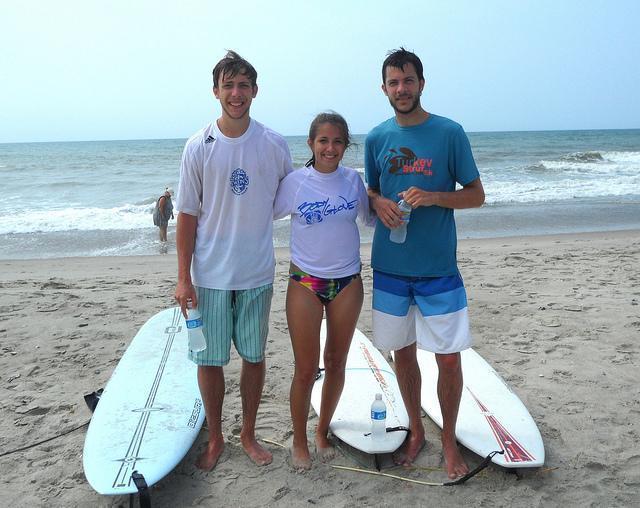How many surfboards are visible?
Give a very brief answer. 3. How many people are visible?
Give a very brief answer. 3. How many airplanes are flying to the left of the person?
Give a very brief answer. 0. 